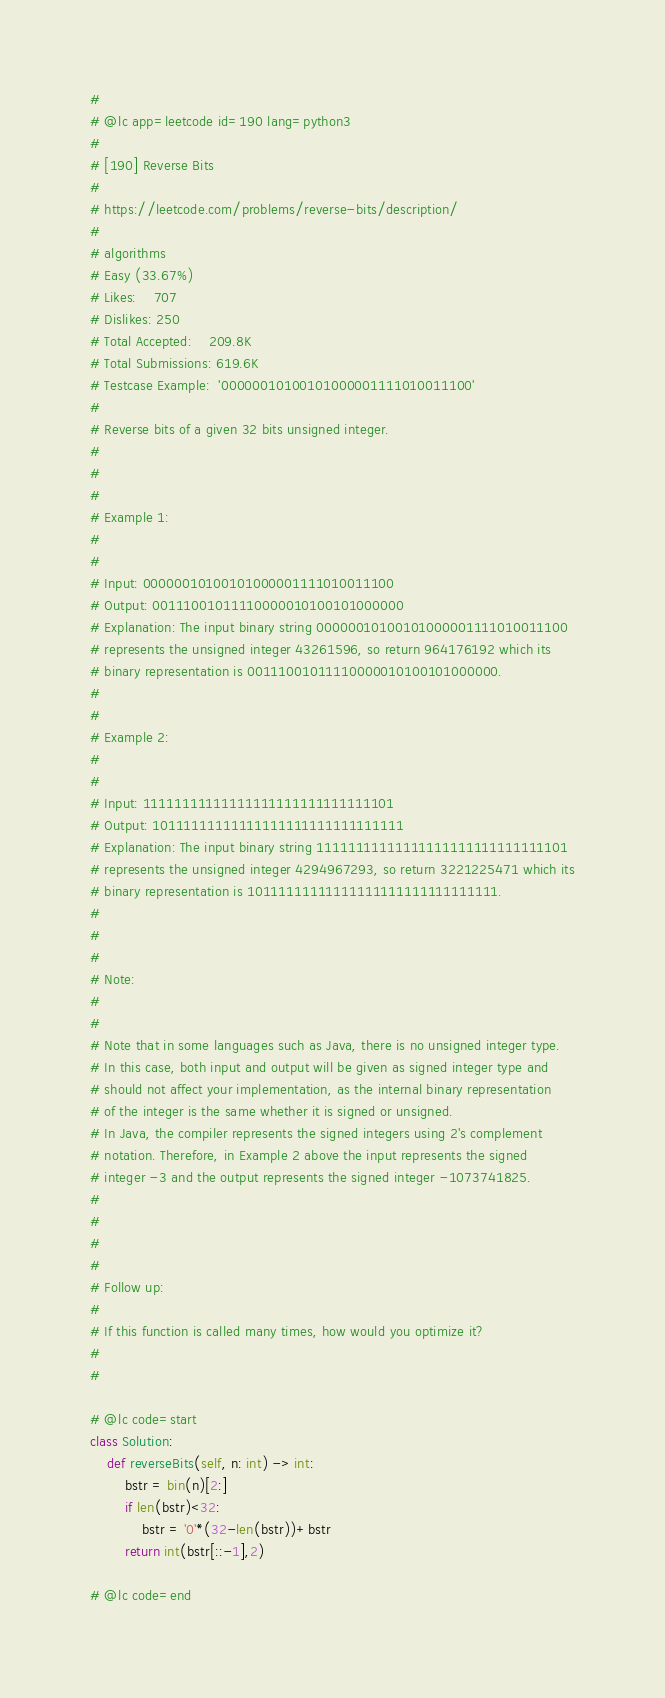Convert code to text. <code><loc_0><loc_0><loc_500><loc_500><_Python_>#
# @lc app=leetcode id=190 lang=python3
#
# [190] Reverse Bits
#
# https://leetcode.com/problems/reverse-bits/description/
#
# algorithms
# Easy (33.67%)
# Likes:    707
# Dislikes: 250
# Total Accepted:    209.8K
# Total Submissions: 619.6K
# Testcase Example:  '00000010100101000001111010011100'
#
# Reverse bits of a given 32 bits unsigned integer.
# 
# 
# 
# Example 1:
# 
# 
# Input: 00000010100101000001111010011100
# Output: 00111001011110000010100101000000
# Explanation: The input binary string 00000010100101000001111010011100
# represents the unsigned integer 43261596, so return 964176192 which its
# binary representation is 00111001011110000010100101000000.
# 
# 
# Example 2:
# 
# 
# Input: 11111111111111111111111111111101
# Output: 10111111111111111111111111111111
# Explanation: The input binary string 11111111111111111111111111111101
# represents the unsigned integer 4294967293, so return 3221225471 which its
# binary representation is 10111111111111111111111111111111.
# 
# 
# 
# Note:
# 
# 
# Note that in some languages such as Java, there is no unsigned integer type.
# In this case, both input and output will be given as signed integer type and
# should not affect your implementation, as the internal binary representation
# of the integer is the same whether it is signed or unsigned.
# In Java, the compiler represents the signed integers using 2's complement
# notation. Therefore, in Example 2 above the input represents the signed
# integer -3 and the output represents the signed integer -1073741825.
# 
# 
# 
# 
# Follow up:
# 
# If this function is called many times, how would you optimize it?
# 
#

# @lc code=start
class Solution:
    def reverseBits(self, n: int) -> int:
        bstr = bin(n)[2:]
        if len(bstr)<32:
            bstr = '0'*(32-len(bstr))+bstr
        return int(bstr[::-1],2)

# @lc code=end

</code> 